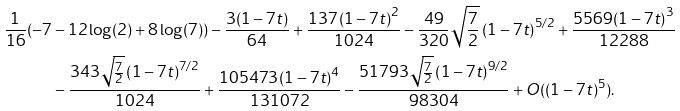<formula> <loc_0><loc_0><loc_500><loc_500>\frac { 1 } { 1 6 } ( - 7 & - 1 2 \log ( 2 ) + 8 \log ( 7 ) ) - \frac { 3 ( 1 - 7 t ) } { 6 4 } + \frac { 1 3 7 \left ( 1 - 7 t \right ) ^ { 2 } } { 1 0 2 4 } - \frac { 4 9 } { 3 2 0 } \sqrt { \frac { 7 } { 2 } } \left ( 1 - 7 t \right ) ^ { 5 / 2 } + \frac { 5 5 6 9 \left ( 1 - 7 t \right ) ^ { 3 } } { 1 2 2 8 8 } \\ & - \frac { 3 4 3 \sqrt { \frac { 7 } { 2 } } \left ( 1 - 7 t \right ) ^ { 7 / 2 } } { 1 0 2 4 } + \frac { 1 0 5 4 7 3 \left ( 1 - 7 t \right ) ^ { 4 } } { 1 3 1 0 7 2 } - \frac { 5 1 7 9 3 \sqrt { \frac { 7 } { 2 } } \left ( 1 - 7 t \right ) ^ { 9 / 2 } } { 9 8 3 0 4 } + O ( ( 1 - 7 t ) ^ { 5 } ) .</formula> 